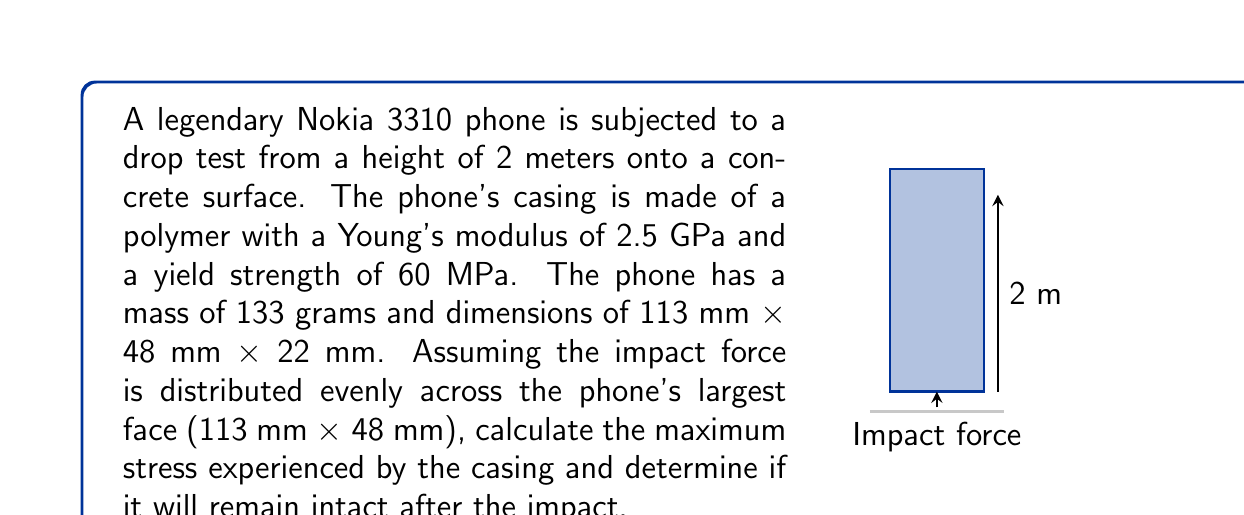Give your solution to this math problem. To solve this problem, we'll follow these steps:

1) Calculate the impact velocity:
   Using the equation $v = \sqrt{2gh}$, where $g = 9.81 \mathrm{m/s^2}$ and $h = 2 \mathrm{m}$
   $$v = \sqrt{2 \times 9.81 \times 2} = 6.26 \mathrm{m/s}$$

2) Calculate the impact force:
   Assume the phone decelerates over a distance of 1 mm (0.001 m)
   Using $F = ma = m\frac{v^2}{2s}$, where $m = 0.133 \mathrm{kg}$ and $s = 0.001 \mathrm{m}$
   $$F = 0.133 \times \frac{6.26^2}{2 \times 0.001} = 2601.5 \mathrm{N}$$

3) Calculate the area of impact:
   $$A = 113 \times 10^{-3} \times 48 \times 10^{-3} = 5.424 \times 10^{-3} \mathrm{m^2}$$

4) Calculate the stress:
   $$\sigma = \frac{F}{A} = \frac{2601.5}{5.424 \times 10^{-3}} = 479,627 \mathrm{Pa} = 0.48 \mathrm{MPa}$$

5) Compare the calculated stress to the yield strength:
   The calculated stress (0.48 MPa) is less than the yield strength (60 MPa)

6) Calculate the strain:
   Using Hooke's Law, $\sigma = E\epsilon$, where $E = 2.5 \mathrm{GPa}$
   $$\epsilon = \frac{\sigma}{E} = \frac{0.48 \times 10^6}{2.5 \times 10^9} = 0.000192 = 0.0192\%$$
Answer: The maximum stress is 0.48 MPa, which is below the yield strength. The casing will remain intact. 